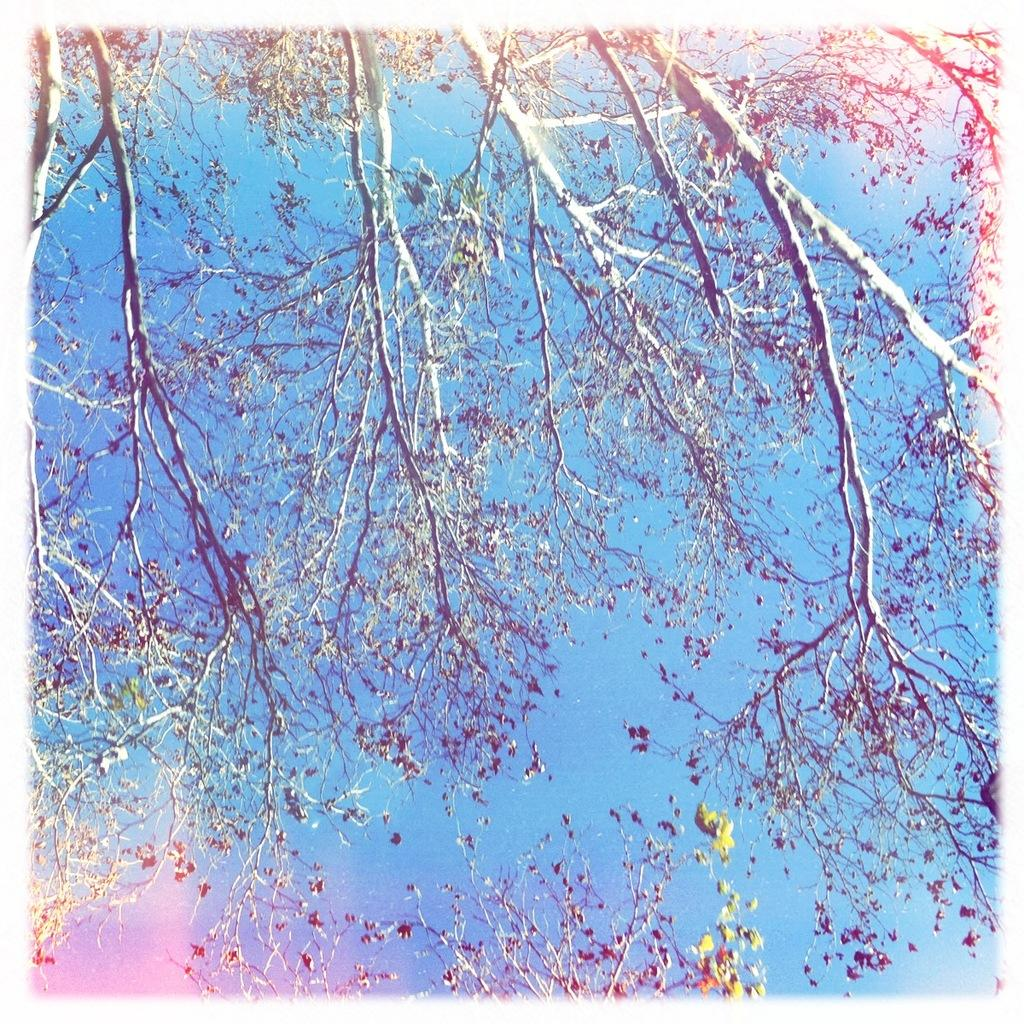What type of vegetation can be seen in the image? There are trees in the image. What part of the natural environment is visible in the image? The sky is visible in the background of the image. Are there any potatoes growing on the trees in the image? There are no potatoes visible in the image, and trees do not typically grow potatoes. 